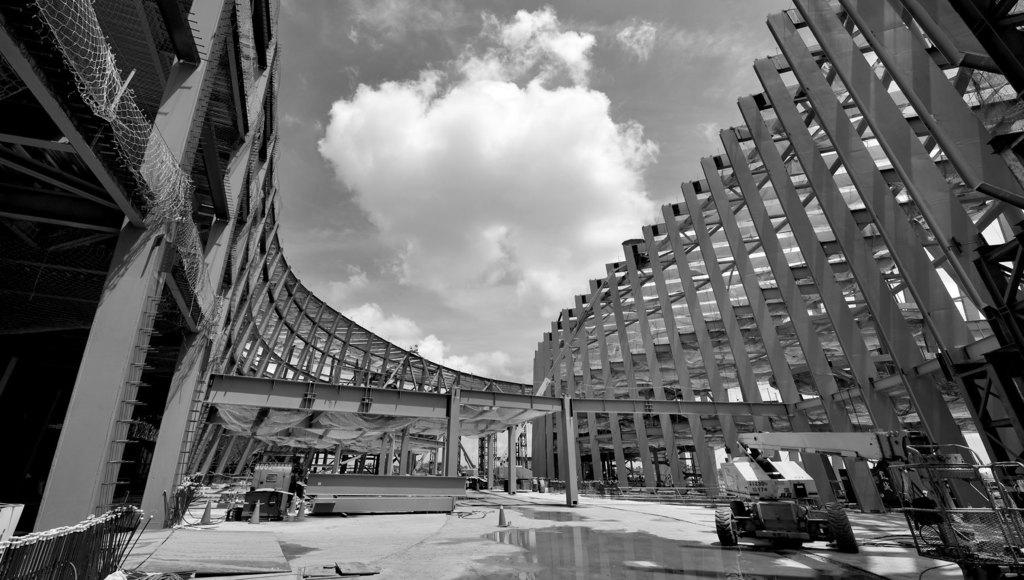What type of construction is taking place in the image? There is a pole construction in the image. What tools or machines are being used for the construction? Construction equipment is visible in the image. What mode of transportation is present in the image? A vehicle is present in the image. What can be seen in the sky in the image? The sky is visible in the image, and clouds are present in the sky. What type of spring is being used to hold the pole in place in the image? There is no spring present in the image; the pole construction is being held in place by other means. 